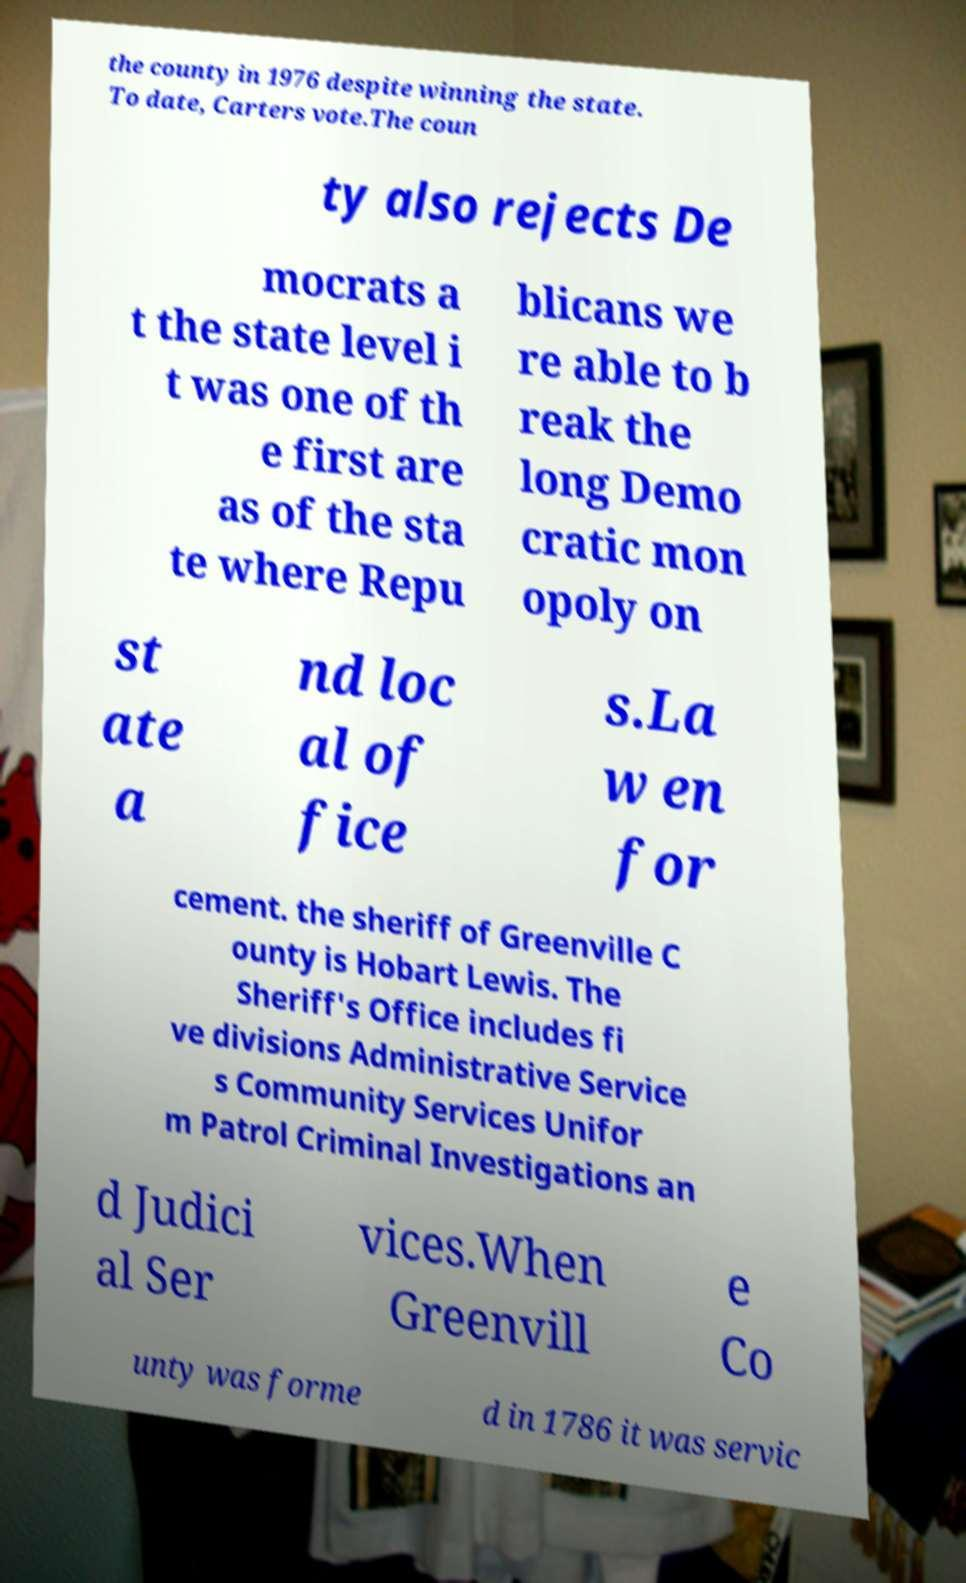Could you assist in decoding the text presented in this image and type it out clearly? the county in 1976 despite winning the state. To date, Carters vote.The coun ty also rejects De mocrats a t the state level i t was one of th e first are as of the sta te where Repu blicans we re able to b reak the long Demo cratic mon opoly on st ate a nd loc al of fice s.La w en for cement. the sheriff of Greenville C ounty is Hobart Lewis. The Sheriff's Office includes fi ve divisions Administrative Service s Community Services Unifor m Patrol Criminal Investigations an d Judici al Ser vices.When Greenvill e Co unty was forme d in 1786 it was servic 